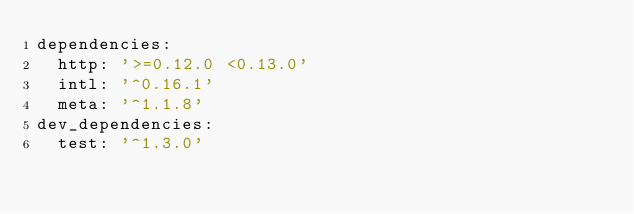<code> <loc_0><loc_0><loc_500><loc_500><_YAML_>dependencies:
  http: '>=0.12.0 <0.13.0'
  intl: '^0.16.1'
  meta: '^1.1.8'
dev_dependencies:
  test: '^1.3.0'
</code> 